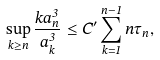<formula> <loc_0><loc_0><loc_500><loc_500>\sup _ { k \geq n } \frac { k a _ { n } ^ { 3 } } { a _ { k } ^ { 3 } } \leq C ^ { \prime } \sum _ { k = 1 } ^ { n - 1 } n \tau _ { n } ,</formula> 